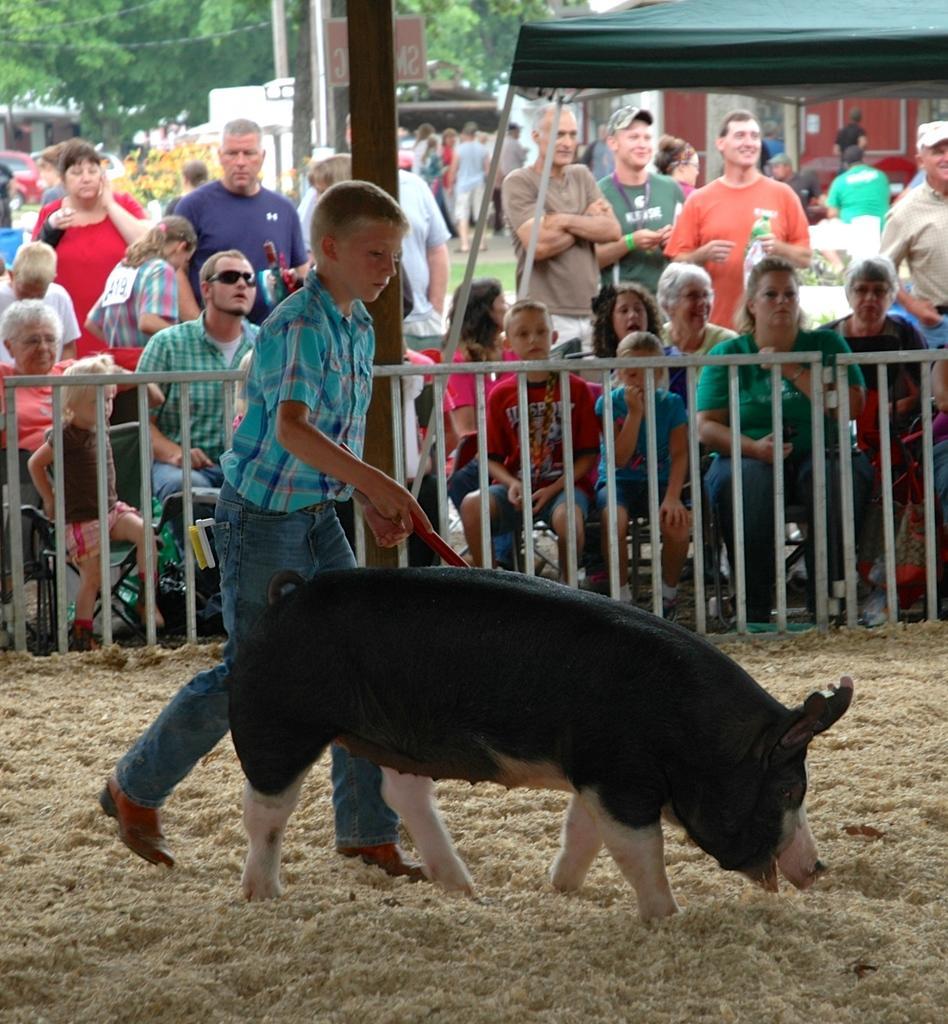Describe this image in one or two sentences. In this picture, We see few people are standing and few are seated and a tent and few houses and trees and I can see a pig and a boy holding a stick in his hand and I can see a metal fence. 